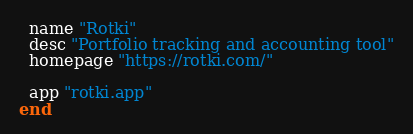Convert code to text. <code><loc_0><loc_0><loc_500><loc_500><_Ruby_>  name "Rotki"
  desc "Portfolio tracking and accounting tool"
  homepage "https://rotki.com/"

  app "rotki.app"
end
</code> 